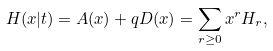<formula> <loc_0><loc_0><loc_500><loc_500>H ( x | t ) = A ( x ) + q D ( x ) = \sum _ { r \geq 0 } x ^ { r } H _ { r } ,</formula> 